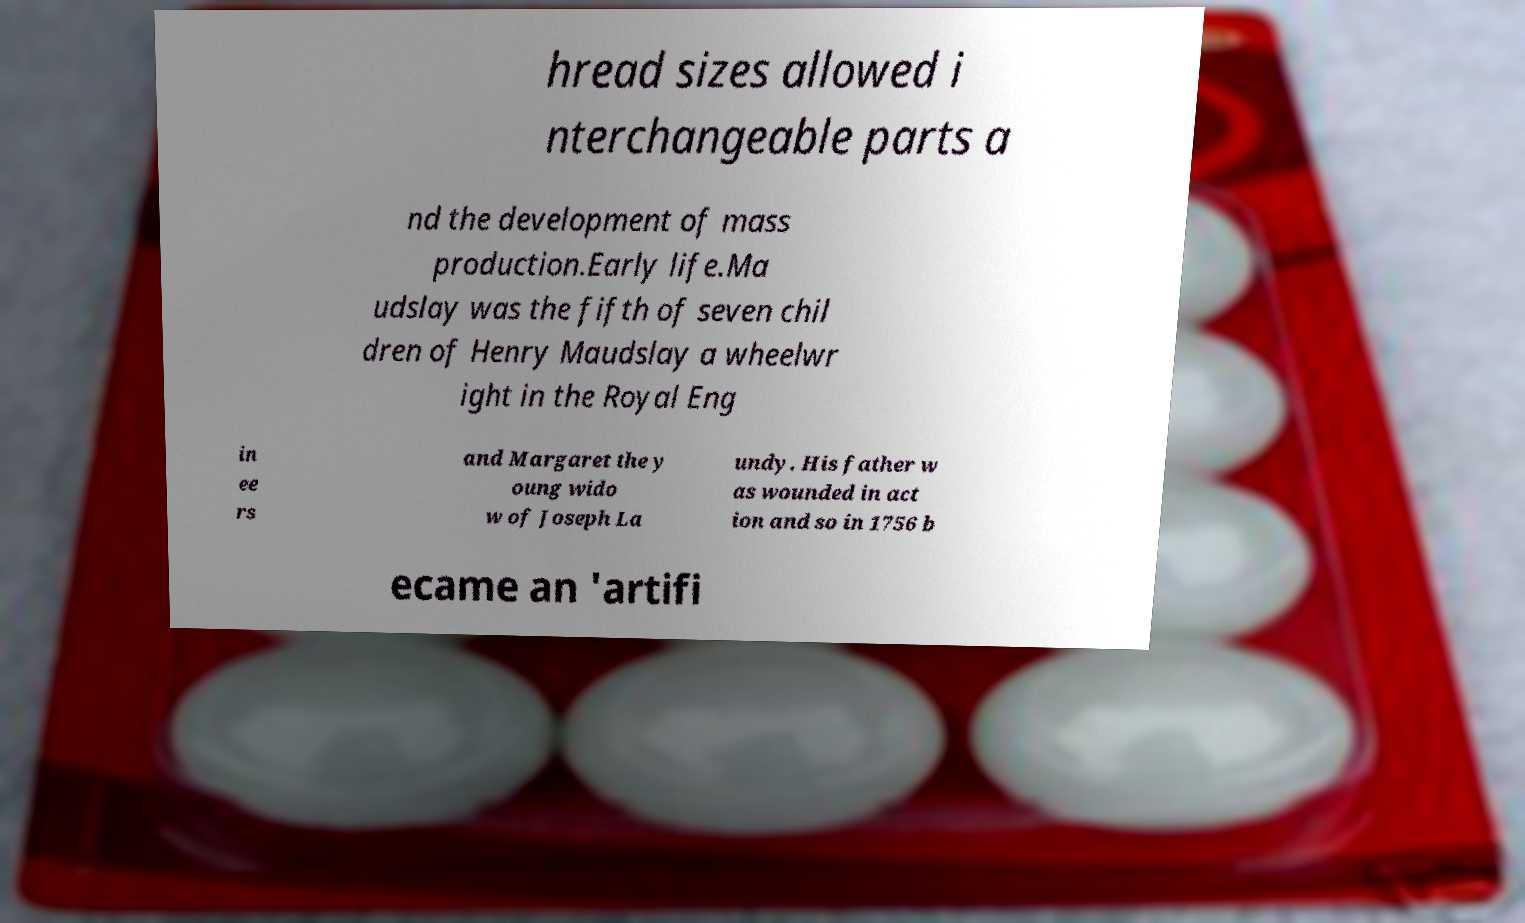I need the written content from this picture converted into text. Can you do that? hread sizes allowed i nterchangeable parts a nd the development of mass production.Early life.Ma udslay was the fifth of seven chil dren of Henry Maudslay a wheelwr ight in the Royal Eng in ee rs and Margaret the y oung wido w of Joseph La undy. His father w as wounded in act ion and so in 1756 b ecame an 'artifi 